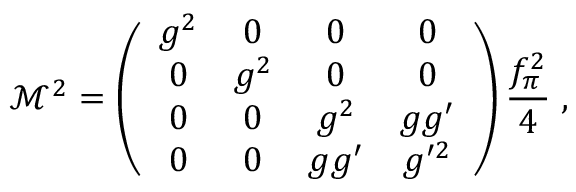Convert formula to latex. <formula><loc_0><loc_0><loc_500><loc_500>\mathcal { M } ^ { 2 } = \left ( \begin{array} { c c c c } { { g ^ { 2 } } } & { 0 } & { 0 } & { 0 } \\ { 0 } & { { g ^ { 2 } } } & { 0 } & { 0 } \\ { 0 } & { 0 } & { { g ^ { 2 } } } & { { g g ^ { \prime } } } \\ { 0 } & { 0 } & { { g g ^ { \prime } } } & { { g ^ { \prime 2 } } } \end{array} \right ) \frac { f _ { \pi } ^ { 2 } } { 4 } \, ,</formula> 